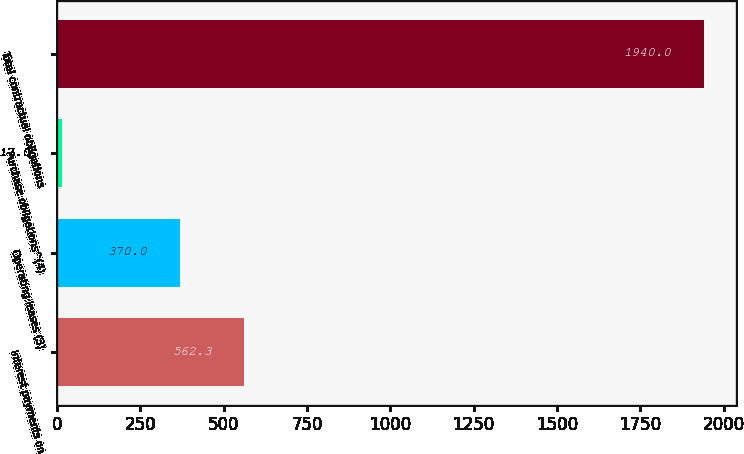Convert chart to OTSL. <chart><loc_0><loc_0><loc_500><loc_500><bar_chart><fcel>Interest payments on<fcel>Operating leases (3)<fcel>Purchase obligations^(4)<fcel>Total contractual obligations<nl><fcel>562.3<fcel>370<fcel>17<fcel>1940<nl></chart> 